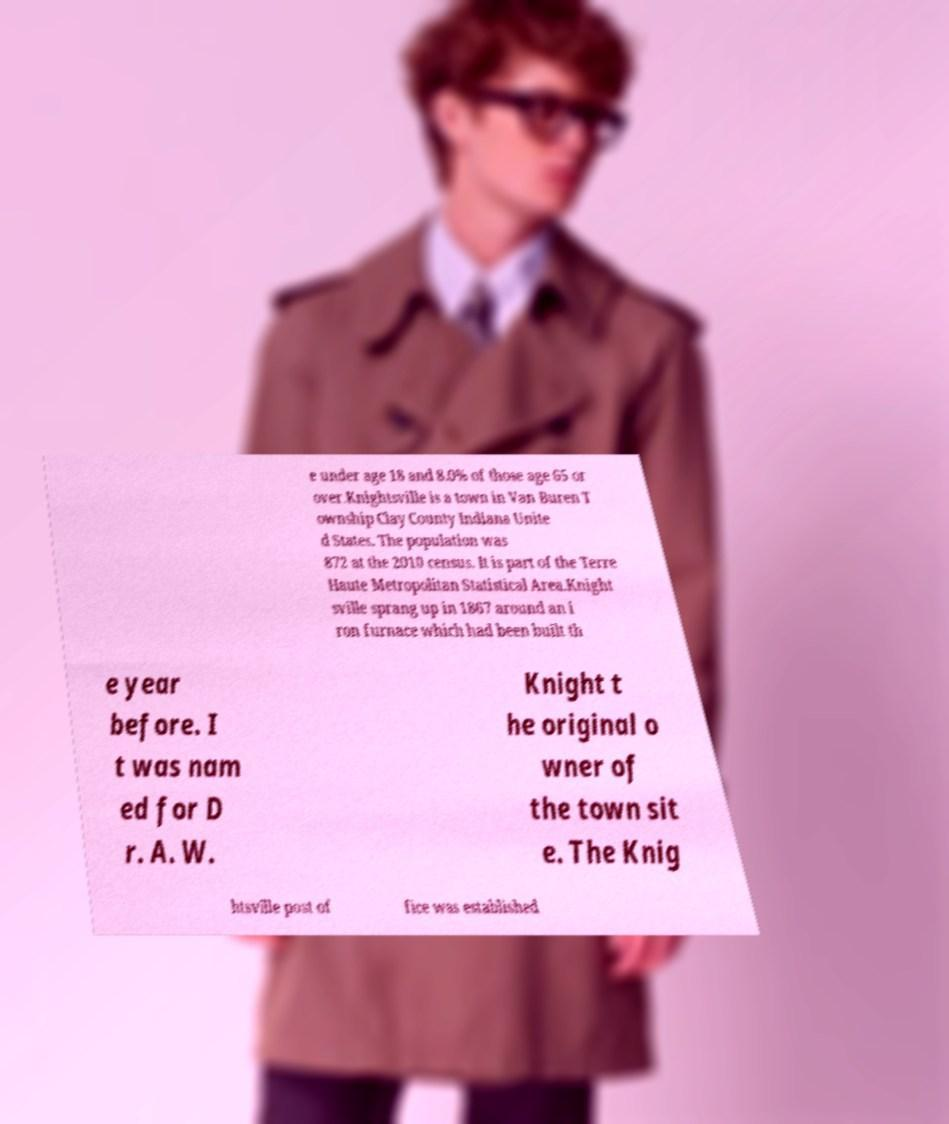Please read and relay the text visible in this image. What does it say? e under age 18 and 8.0% of those age 65 or over.Knightsville is a town in Van Buren T ownship Clay County Indiana Unite d States. The population was 872 at the 2010 census. It is part of the Terre Haute Metropolitan Statistical Area.Knight sville sprang up in 1867 around an i ron furnace which had been built th e year before. I t was nam ed for D r. A. W. Knight t he original o wner of the town sit e. The Knig htsville post of fice was established 